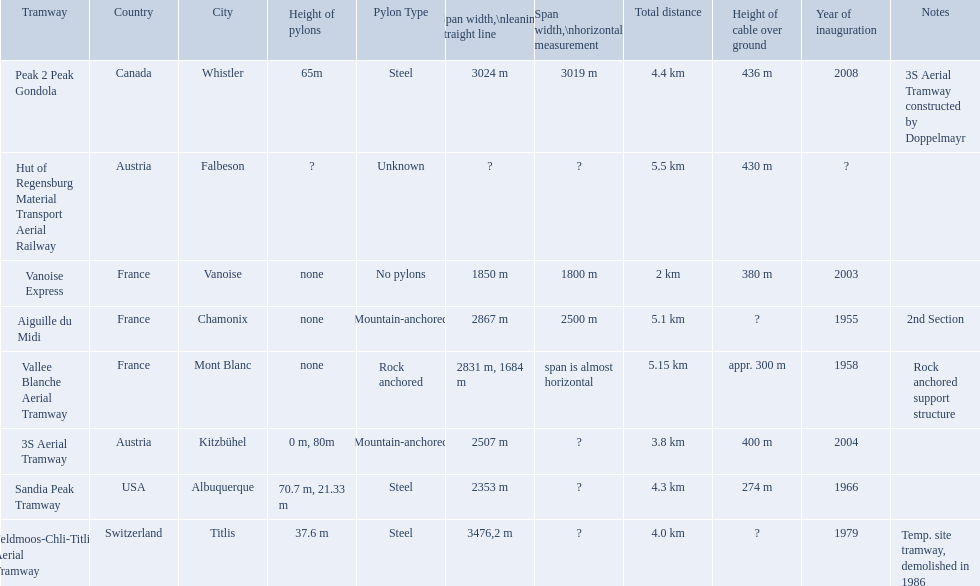Which tramways are in france? Vanoise Express, Aiguille du Midi, Vallee Blanche Aerial Tramway. Which of those were inaugurated in the 1950? Aiguille du Midi, Vallee Blanche Aerial Tramway. Which of these tramways span is not almost horizontal? Aiguille du Midi. Could you parse the entire table as a dict? {'header': ['Tramway', 'Country', 'City', 'Height of pylons', 'Pylon Type', 'Span\xa0width,\\nleaning straight line', 'Span width,\\nhorizontal measurement', 'Total distance', 'Height of cable over ground', 'Year of inauguration', 'Notes'], 'rows': [['Peak 2 Peak Gondola', 'Canada', 'Whistler', '65m', 'Steel', '3024 m', '3019 m', '4.4 km', '436 m', '2008', '3S Aerial Tramway constructed by Doppelmayr'], ['Hut of Regensburg Material Transport Aerial Railway', 'Austria', 'Falbeson', '?', 'Unknown', '?', '?', '5.5 km', '430 m', '?', ''], ['Vanoise Express', 'France', 'Vanoise', 'none', 'No pylons', '1850 m', '1800 m', '2 km', '380 m', '2003', ''], ['Aiguille du Midi', 'France', 'Chamonix', 'none', 'Mountain-anchored', '2867 m', '2500 m', '5.1 km', '?', '1955', '2nd Section'], ['Vallee Blanche Aerial Tramway', 'France', 'Mont Blanc', 'none', 'Rock anchored', '2831 m, 1684 m', 'span is almost horizontal', '5.15 km', 'appr. 300 m', '1958', 'Rock anchored support structure'], ['3S Aerial Tramway', 'Austria', 'Kitzbühel', '0 m, 80m', 'Mountain-anchored', '2507 m', '?', '3.8 km', '400 m', '2004', ''], ['Sandia Peak Tramway', 'USA', 'Albuquerque', '70.7 m, 21.33 m', 'Steel', '2353 m', '?', '4.3 km', '274 m', '1966', ''], ['Feldmoos-Chli-Titlis Aerial Tramway', 'Switzerland', 'Titlis', '37.6 m', 'Steel', '3476,2 m', '?', '4.0 km', '?', '1979', 'Temp. site tramway, demolished in 1986']]} What are all of the tramways? Peak 2 Peak Gondola, Hut of Regensburg Material Transport Aerial Railway, Vanoise Express, Aiguille du Midi, Vallee Blanche Aerial Tramway, 3S Aerial Tramway, Sandia Peak Tramway, Feldmoos-Chli-Titlis Aerial Tramway. When were they inaugurated? 2008, ?, 2003, 1955, 1958, 2004, 1966, 1979. Now, between 3s aerial tramway and aiguille du midi, which was inaugurated first? Aiguille du Midi. When was the aiguille du midi tramway inaugurated? 1955. When was the 3s aerial tramway inaugurated? 2004. Which one was inaugurated first? Aiguille du Midi. 